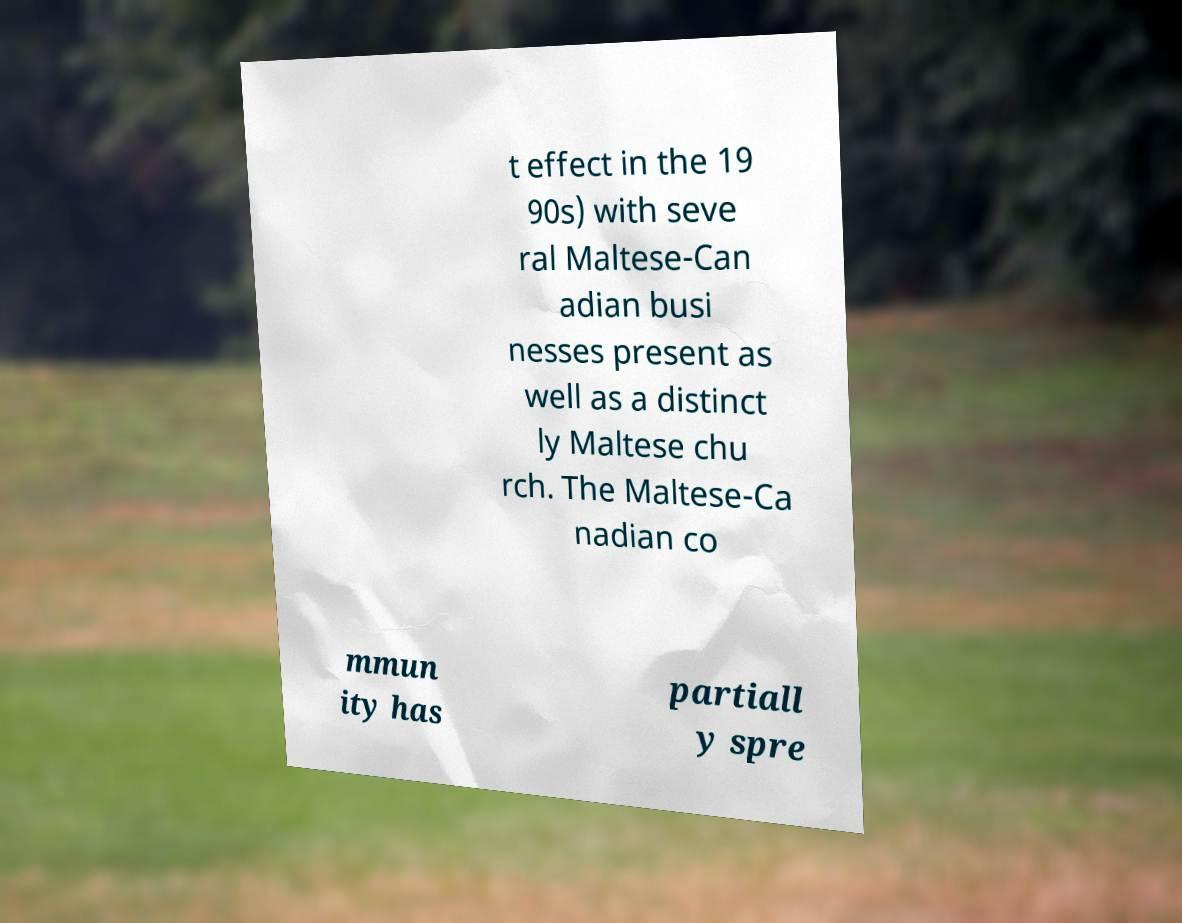Can you accurately transcribe the text from the provided image for me? t effect in the 19 90s) with seve ral Maltese-Can adian busi nesses present as well as a distinct ly Maltese chu rch. The Maltese-Ca nadian co mmun ity has partiall y spre 